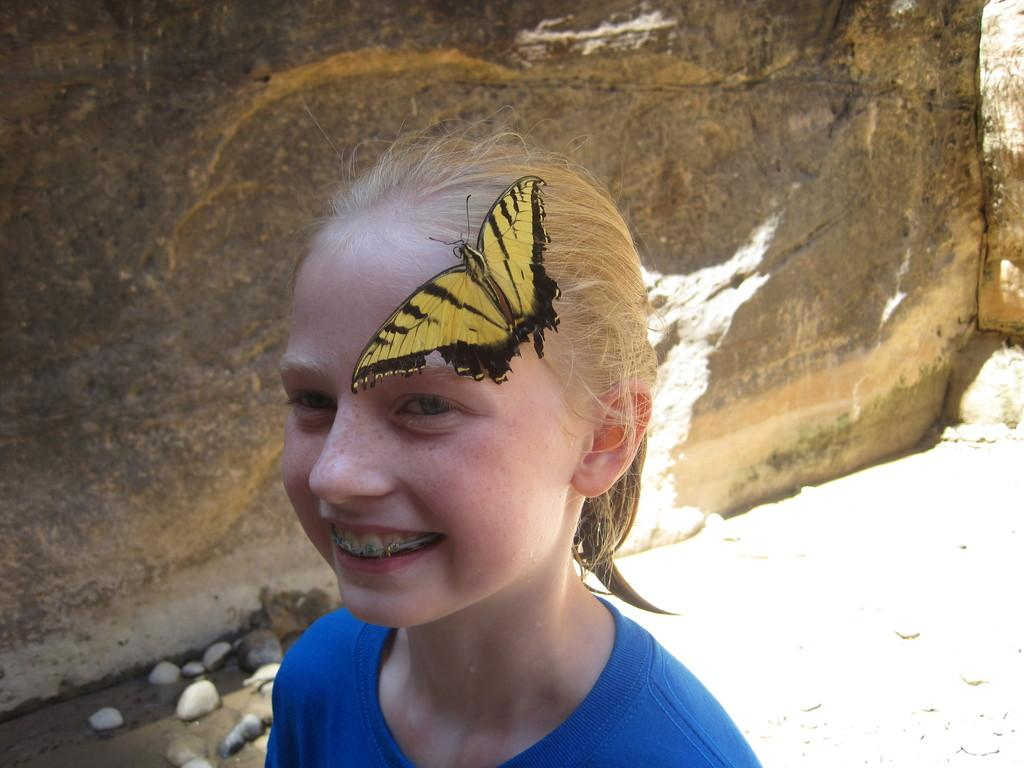Who is present in the image? There is a girl in the image. What is the girl doing in the image? The girl is smiling in the image. What is on the girl in the image? There is a butterfly on the girl. What can be seen on the ground in the background of the image? There are stones on the ground in the background of the image. What is visible in the background of the image? There is a wall visible in the background of the image. What type of cherry is the girl holding in the image? There is no cherry present in the image; the girl has a butterfly on her. What cast is the girl a part of in the image? There is: There is no reference to a cast or any theatrical performance in the image, so it cannot be determined. 